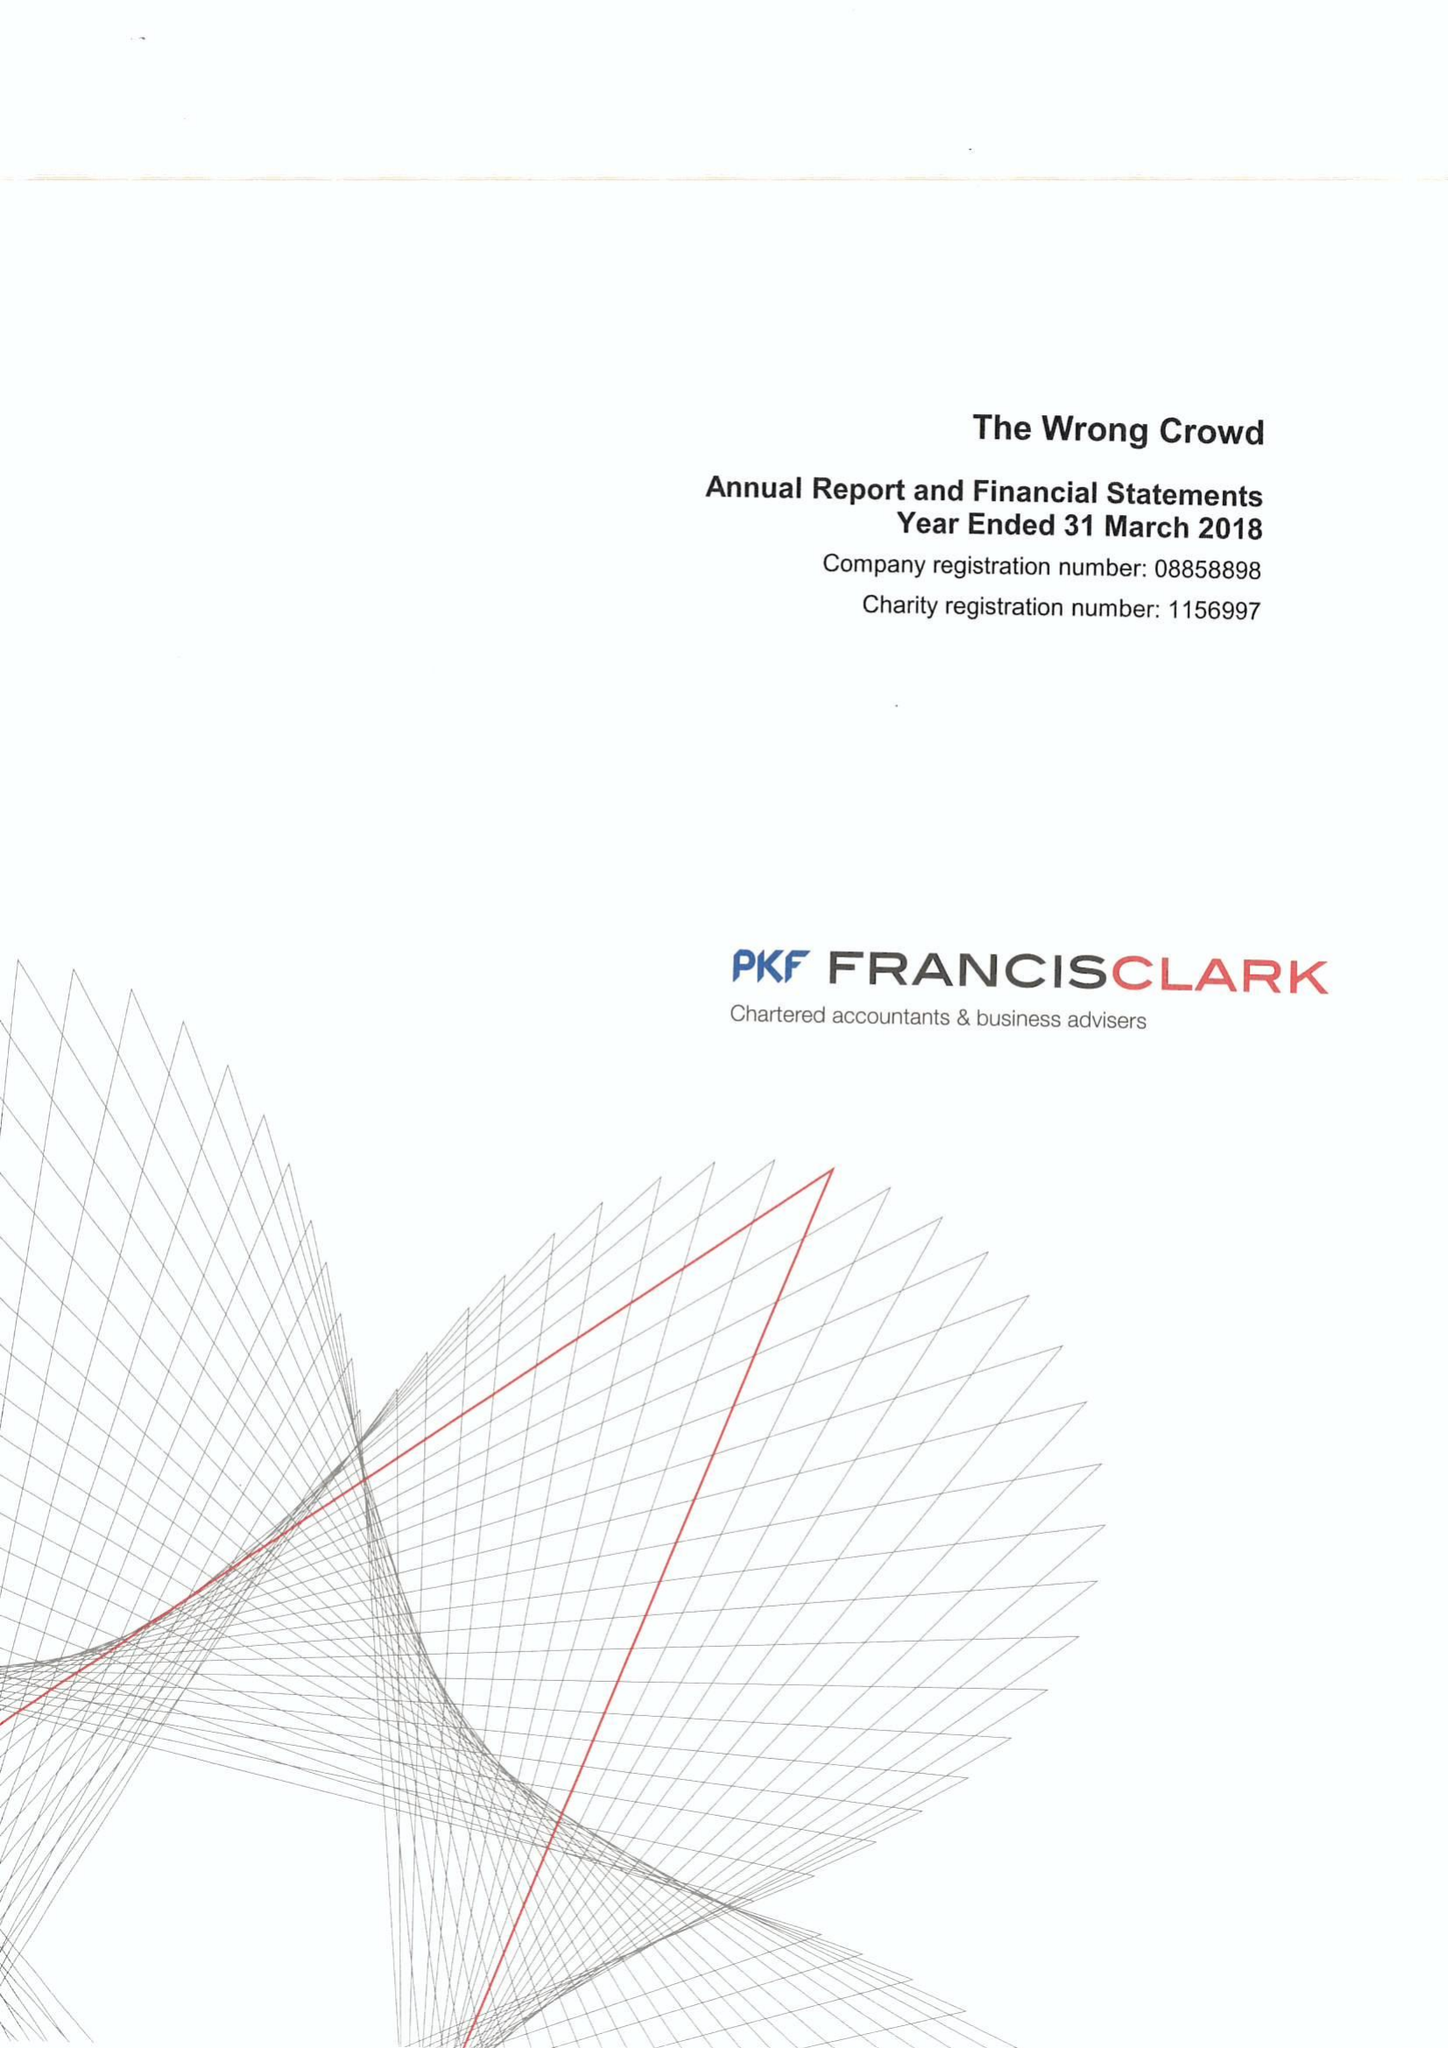What is the value for the report_date?
Answer the question using a single word or phrase. 2018-03-31 